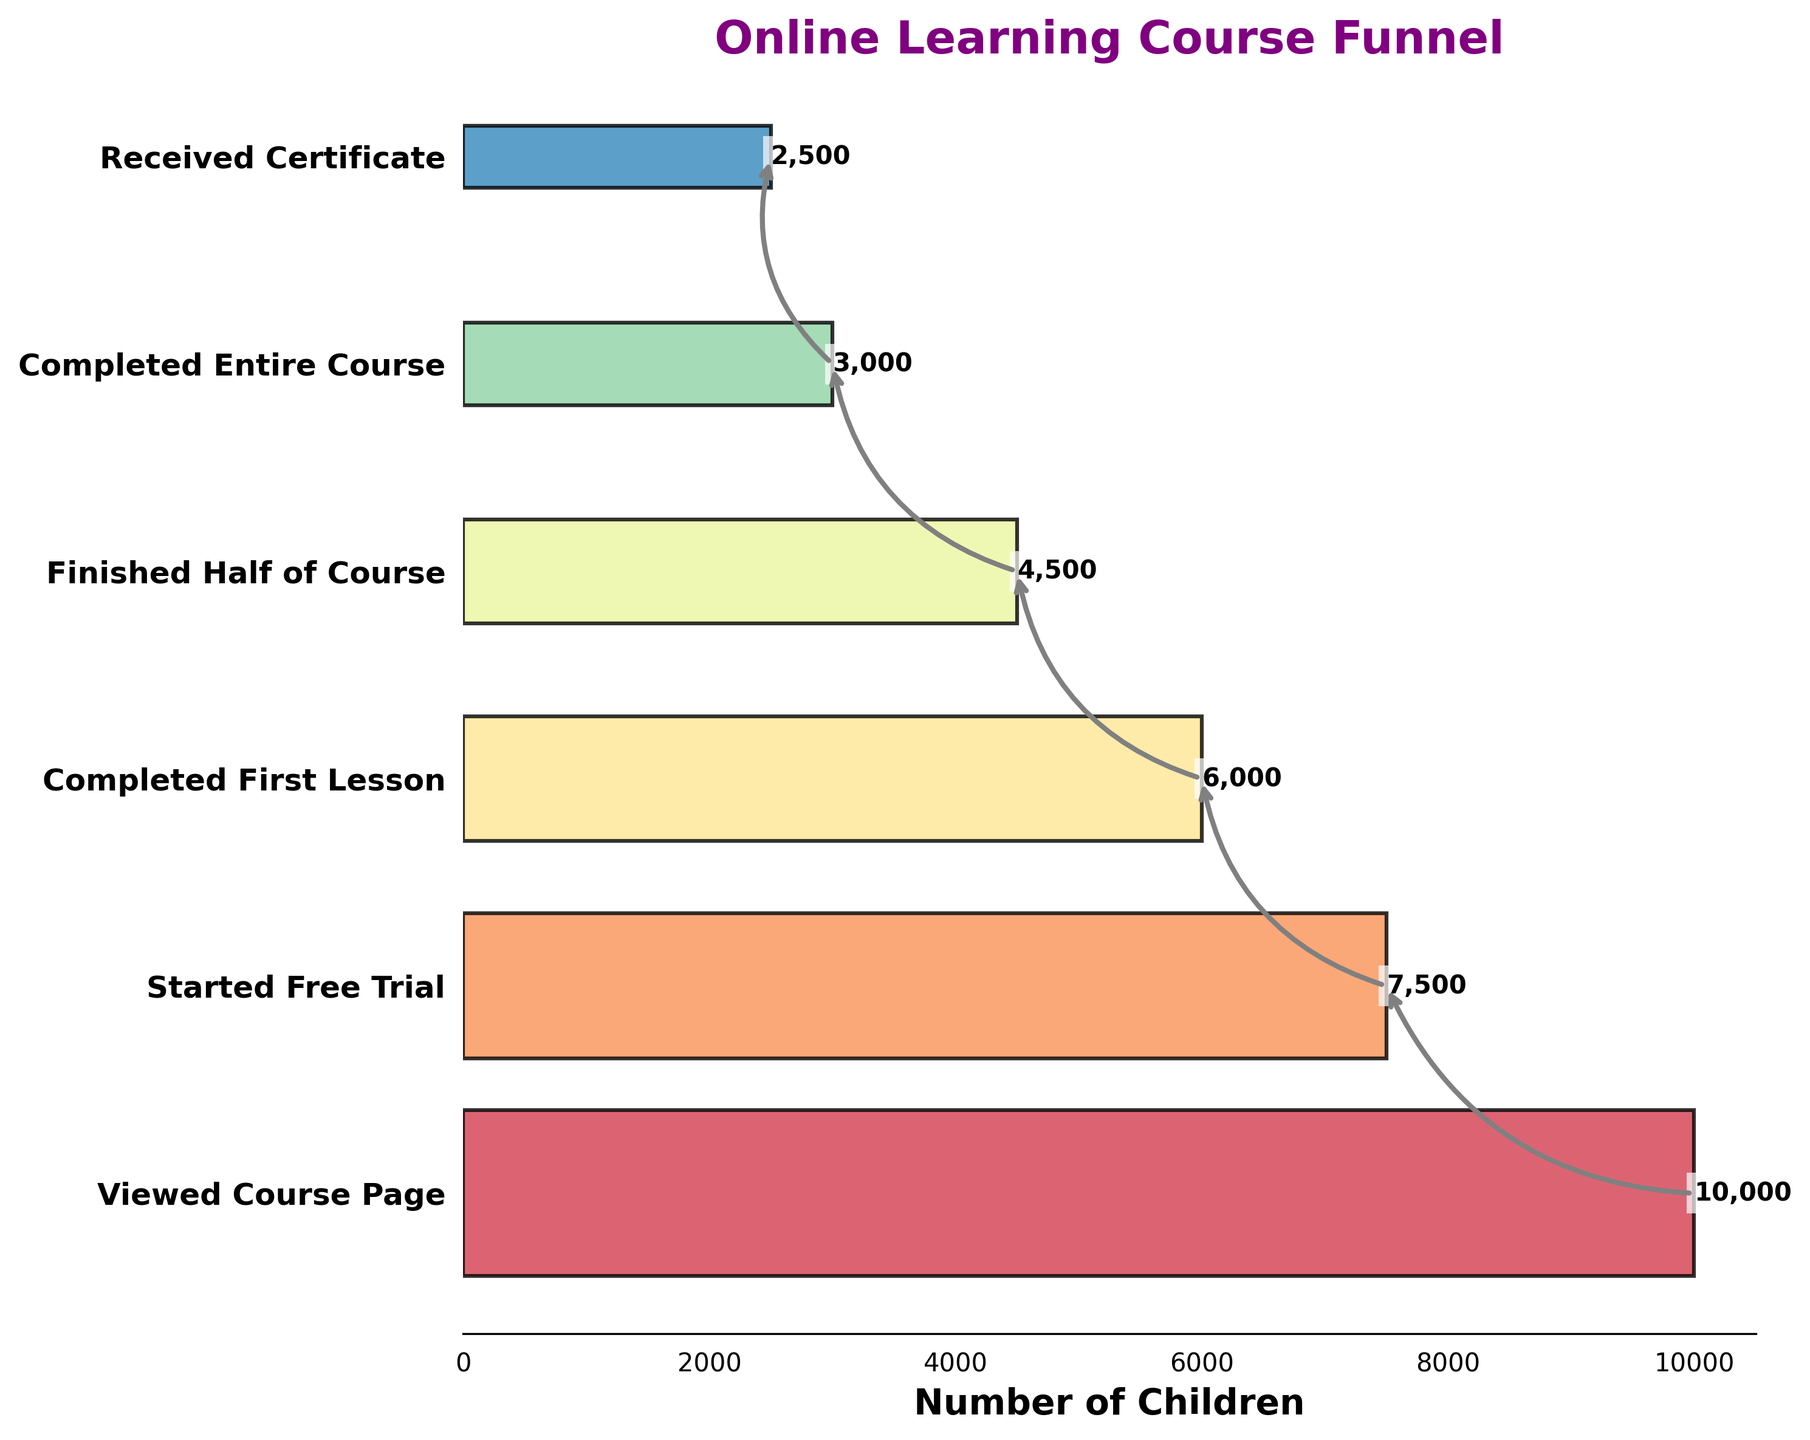What is the title of the chart? The title of the chart is displayed at the top in a larger, bold font
Answer: Online Learning Course Funnel How many stages are there in the funnel? The number of stages can be counted by looking at the distinct y-axis labels
Answer: 6 Which stage had the highest number of children? The stage with the highest bar value on the x-axis indicated the highest number of children
Answer: Viewed Course Page How many children completed the entire course? The bar corresponding to the 'Completed Entire Course' stage shows this value on the x-axis
Answer: 3000 What is the total number of children who received the certificate? Find the value next to the stage named 'Received Certificate'
Answer: 2500 